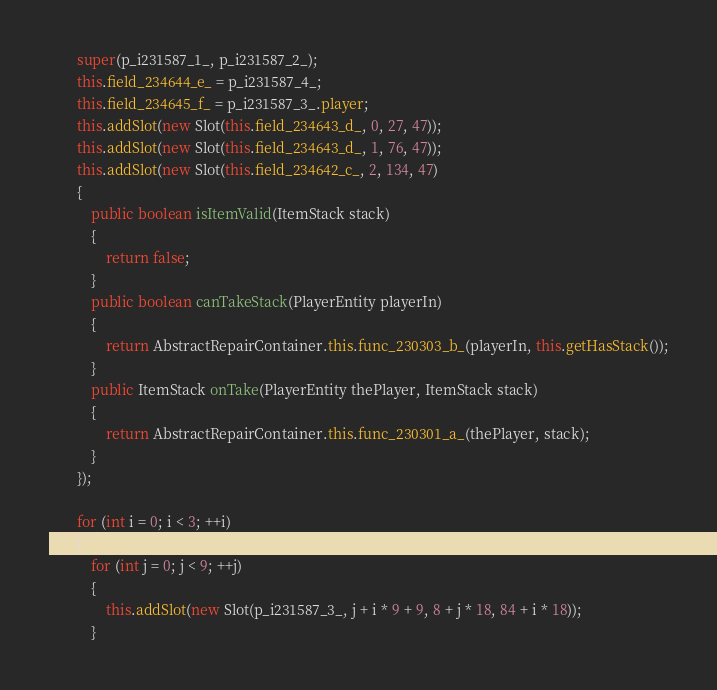Convert code to text. <code><loc_0><loc_0><loc_500><loc_500><_Java_>        super(p_i231587_1_, p_i231587_2_);
        this.field_234644_e_ = p_i231587_4_;
        this.field_234645_f_ = p_i231587_3_.player;
        this.addSlot(new Slot(this.field_234643_d_, 0, 27, 47));
        this.addSlot(new Slot(this.field_234643_d_, 1, 76, 47));
        this.addSlot(new Slot(this.field_234642_c_, 2, 134, 47)
        {
            public boolean isItemValid(ItemStack stack)
            {
                return false;
            }
            public boolean canTakeStack(PlayerEntity playerIn)
            {
                return AbstractRepairContainer.this.func_230303_b_(playerIn, this.getHasStack());
            }
            public ItemStack onTake(PlayerEntity thePlayer, ItemStack stack)
            {
                return AbstractRepairContainer.this.func_230301_a_(thePlayer, stack);
            }
        });

        for (int i = 0; i < 3; ++i)
        {
            for (int j = 0; j < 9; ++j)
            {
                this.addSlot(new Slot(p_i231587_3_, j + i * 9 + 9, 8 + j * 18, 84 + i * 18));
            }</code> 